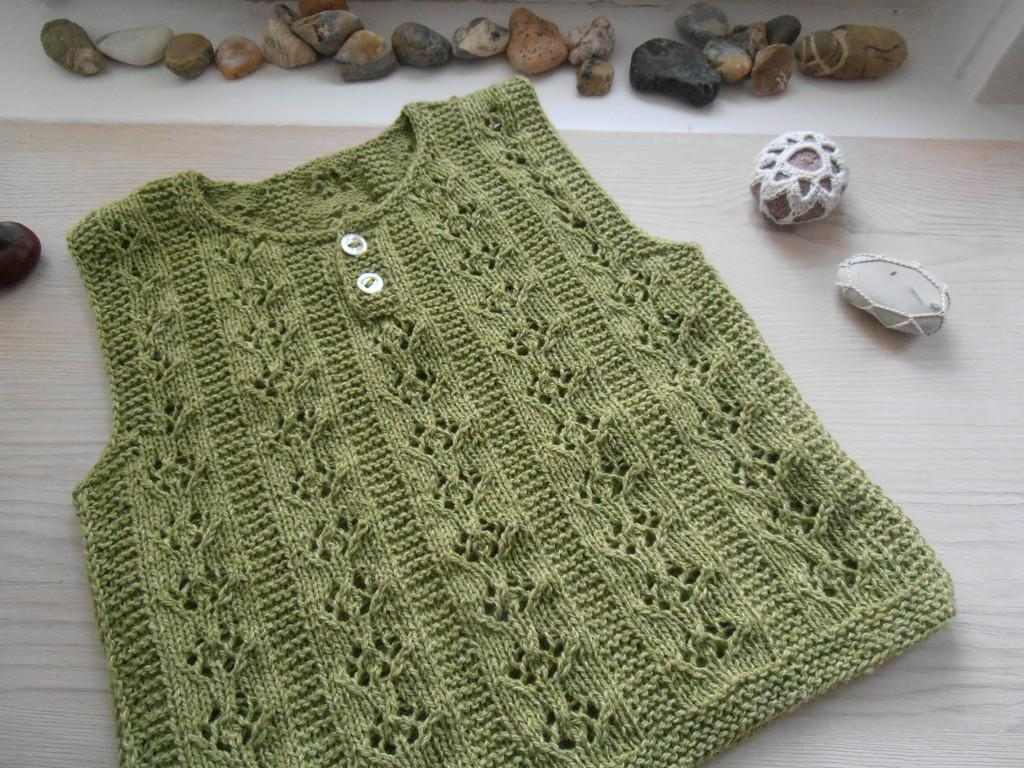What type of clothing is on the table in the image? There is a green color dress on the table. What type of objects can be seen besides the dress in the image? There are colorful rocks in the image. Is there any fabric covering any of the items in the image? Yes, a woolen cloth is covering one of the items in the image. Can you tell me how much butter is on the green color dress in the image? There is no butter present on the green color dress or any other item in the image. 